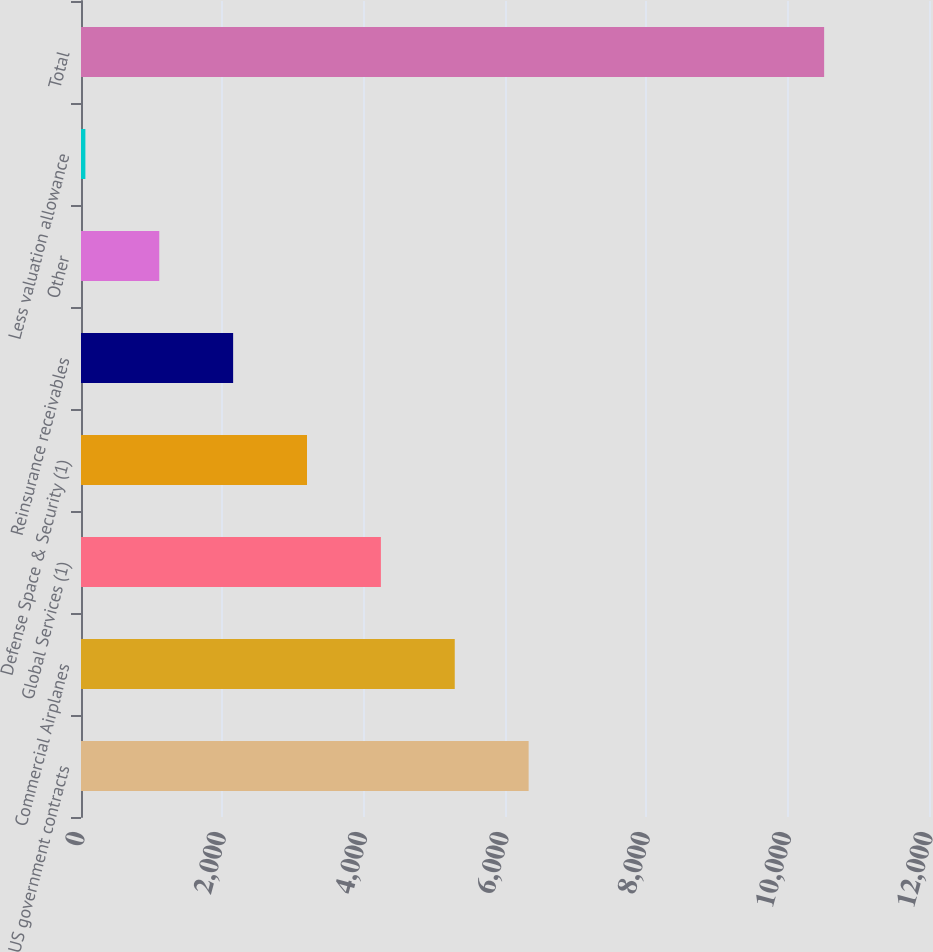Convert chart to OTSL. <chart><loc_0><loc_0><loc_500><loc_500><bar_chart><fcel>US government contracts<fcel>Commercial Airplanes<fcel>Global Services (1)<fcel>Defense Space & Security (1)<fcel>Reinsurance receivables<fcel>Other<fcel>Less valuation allowance<fcel>Total<nl><fcel>6334.4<fcel>5289<fcel>4243.6<fcel>3198.2<fcel>2152.8<fcel>1107.4<fcel>62<fcel>10516<nl></chart> 